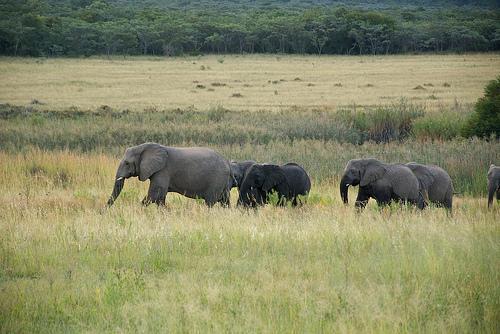How many kinds of animals are in the photo?
Give a very brief answer. 1. 